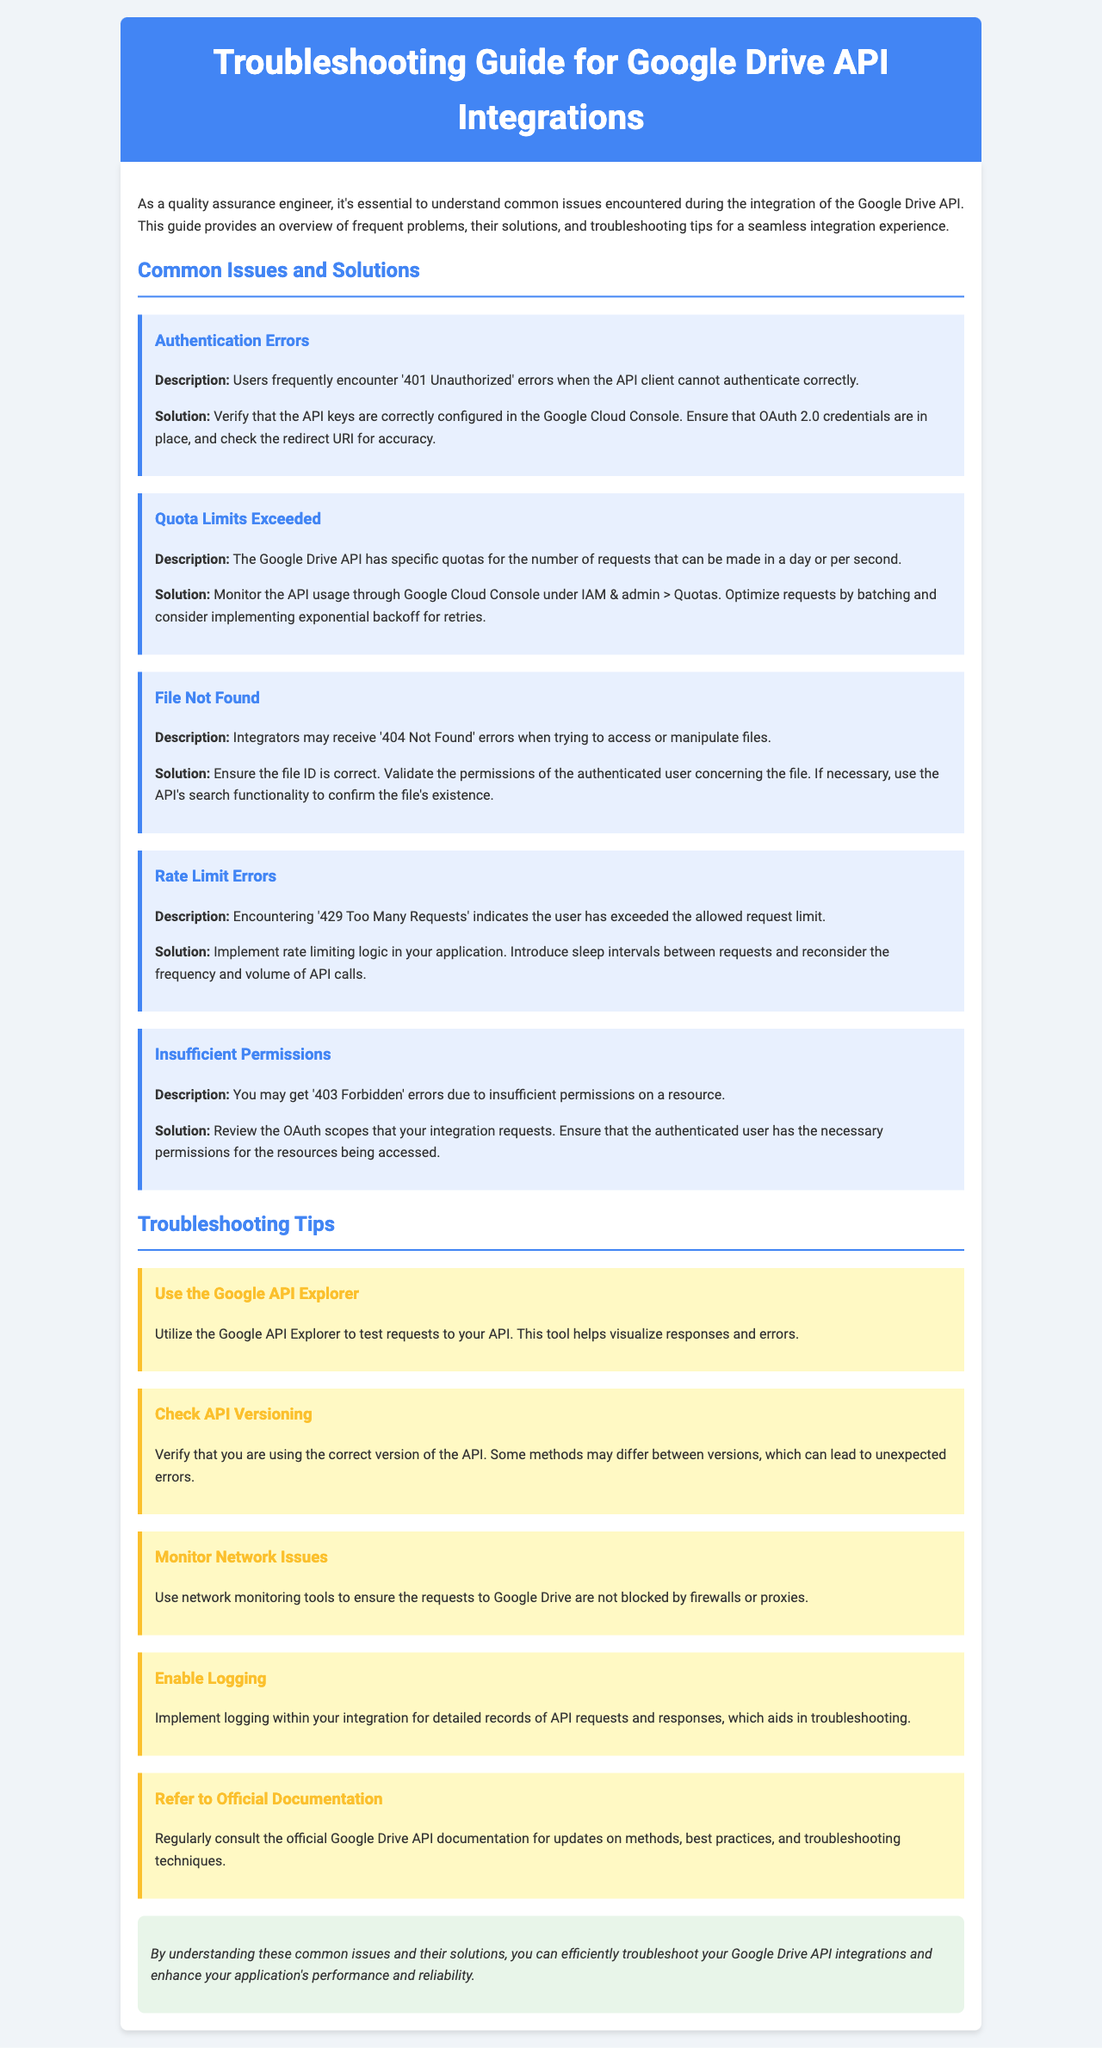What is the title of the guide? The title of the guide is displayed prominently at the top of the document, indicating its focus on troubleshooting.
Answer: Troubleshooting Guide for Google Drive API Integrations What is a common cause of '401 Unauthorized' errors? The document mentions common issues and their solutions, stating that this error is often due to authentication failures.
Answer: Incorrect API keys What should you monitor to avoid exceeding quotas? The document refers to a specific section in the Google Cloud Console dedicated to API usage.
Answer: API usage What does a '429 Too Many Requests' error indicate? This error message is explained in the context of request limitations within the Google Drive API.
Answer: Exceeded request limit Which tool can help test requests to the API? The document suggests a specific tool that allows users to visualize responses to API requests.
Answer: Google API Explorer What specific implementation is suggested to handle rate limit errors? The document advises introducing a certain practice to help manage request frequency.
Answer: Sleep intervals What documentation should be reviewed for best practices? The document specifically mentions a type of resource essential for keeping updated on API techniques.
Answer: Official Google Drive API documentation What error is indicated by '403 Forbidden'? This error reflects issues related to permissions, as described in the solutions section of the document.
Answer: Insufficient permissions How should files be validated if a '404 Not Found' error occurs? The document provides a solution for confirming file existence, which involves a specific API functionality.
Answer: Use the API's search functionality 